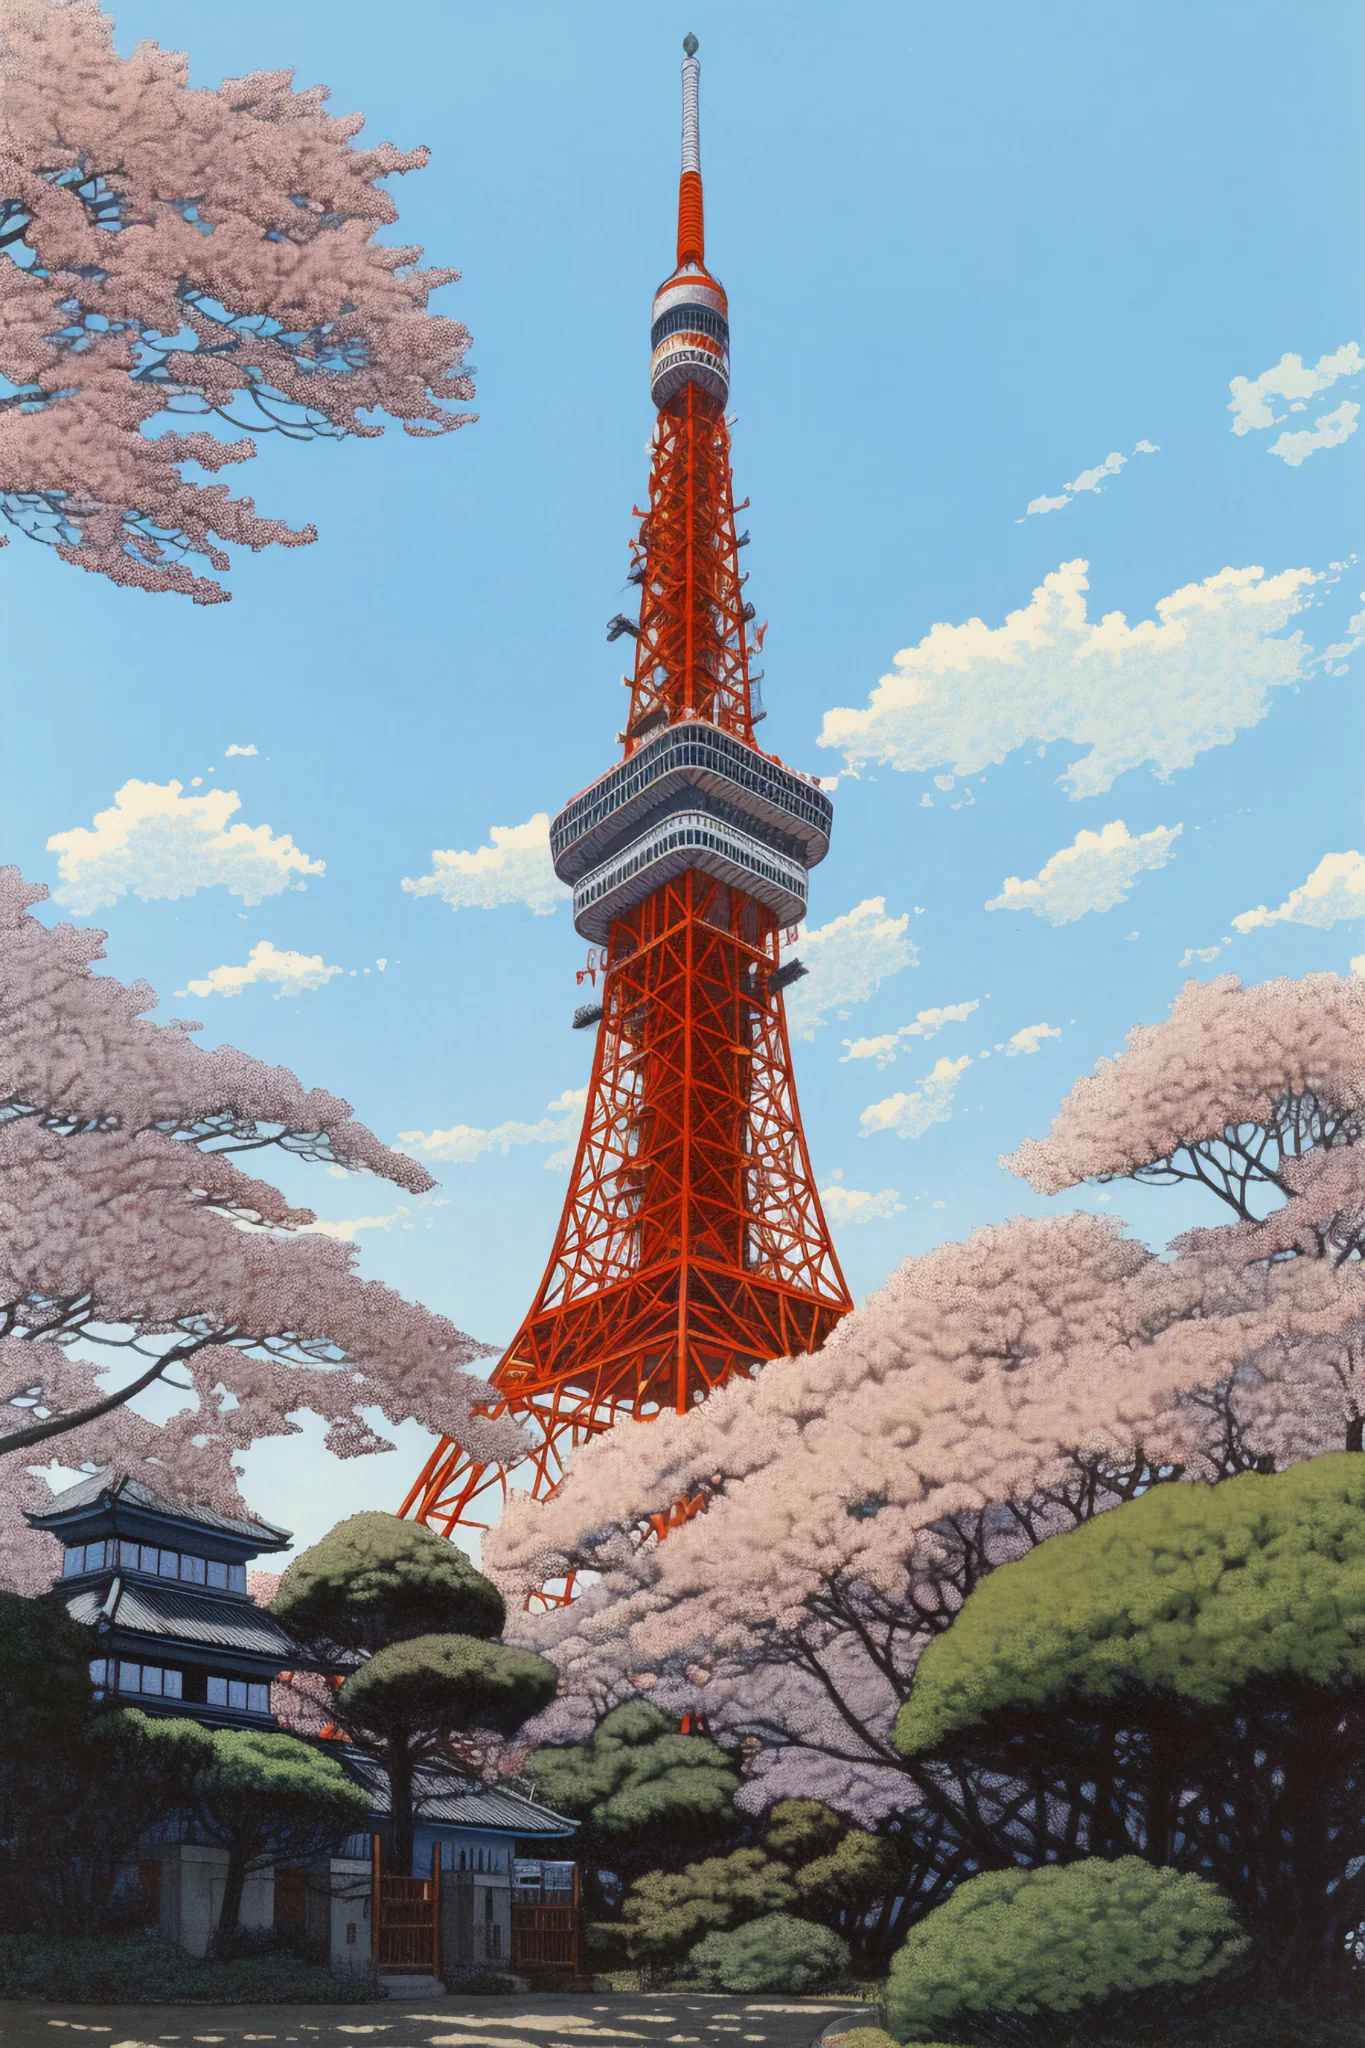What are the key elements in this picture? The image captures the iconic Tokyo Tower, a renowned landmark in Japan. The tower, painted in a bright orange color, stands tall against a clear blue sky. From this perspective, we're looking up at the tower from below, giving a sense of its impressive height. Surrounding the base of the tower, you can see an array of pink cherry blossom trees in full bloom, along with some green shrubbery, adding a touch of natural beauty to the urban landscape. The combination of the tower's striking color, the soft pink blossoms, and the clear blue sky creates a visually appealing contrast. 